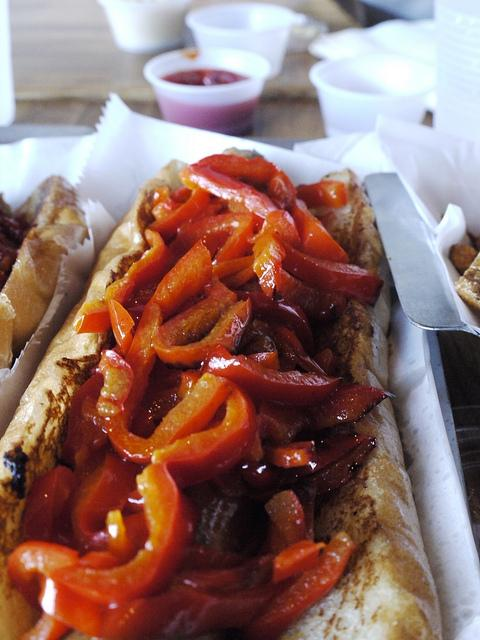What is on top of the sandwich? Please explain your reasoning. red peppers. There are sliced vegetables on top of the sandwich. 